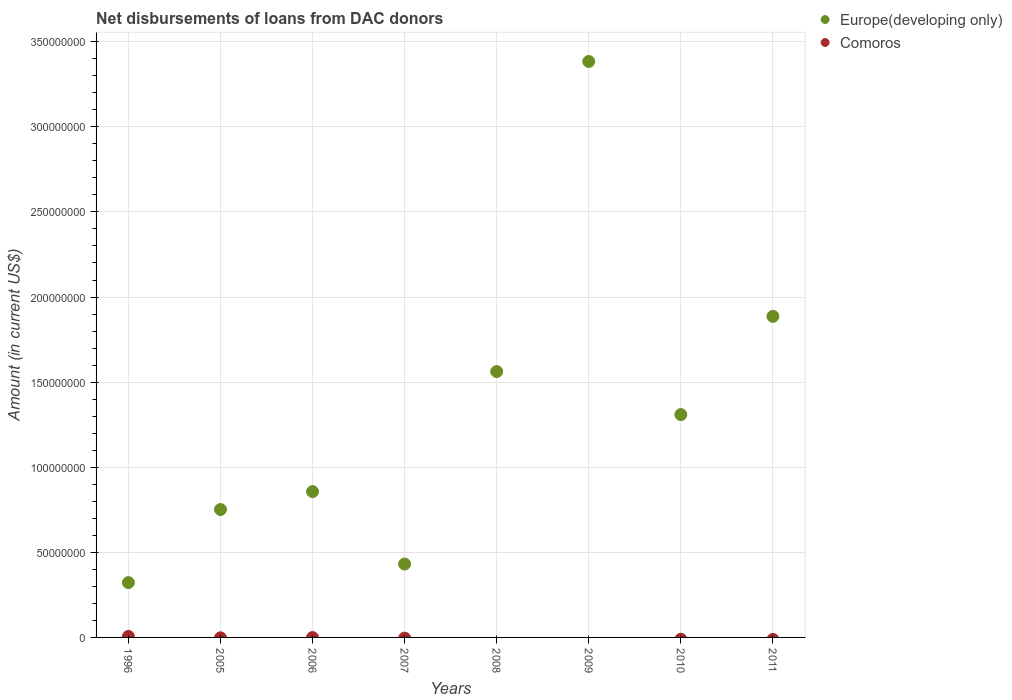Is the number of dotlines equal to the number of legend labels?
Your answer should be compact. No. What is the amount of loans disbursed in Comoros in 2009?
Your response must be concise. 0. Across all years, what is the maximum amount of loans disbursed in Comoros?
Your response must be concise. 5.95e+05. In which year was the amount of loans disbursed in Comoros maximum?
Provide a succinct answer. 1996. What is the total amount of loans disbursed in Europe(developing only) in the graph?
Your answer should be very brief. 1.05e+09. What is the difference between the amount of loans disbursed in Europe(developing only) in 2010 and that in 2011?
Your answer should be very brief. -5.77e+07. What is the difference between the amount of loans disbursed in Europe(developing only) in 2011 and the amount of loans disbursed in Comoros in 2005?
Your answer should be compact. 1.89e+08. What is the average amount of loans disbursed in Europe(developing only) per year?
Provide a succinct answer. 1.31e+08. In the year 1996, what is the difference between the amount of loans disbursed in Europe(developing only) and amount of loans disbursed in Comoros?
Provide a short and direct response. 3.16e+07. What is the ratio of the amount of loans disbursed in Europe(developing only) in 2006 to that in 2007?
Offer a terse response. 1.99. Is the amount of loans disbursed in Europe(developing only) in 2006 less than that in 2011?
Make the answer very short. Yes. What is the difference between the highest and the second highest amount of loans disbursed in Europe(developing only)?
Give a very brief answer. 1.50e+08. What is the difference between the highest and the lowest amount of loans disbursed in Comoros?
Give a very brief answer. 5.95e+05. Is the sum of the amount of loans disbursed in Europe(developing only) in 1996 and 2011 greater than the maximum amount of loans disbursed in Comoros across all years?
Provide a short and direct response. Yes. Does the amount of loans disbursed in Europe(developing only) monotonically increase over the years?
Ensure brevity in your answer.  No. Is the amount of loans disbursed in Comoros strictly less than the amount of loans disbursed in Europe(developing only) over the years?
Ensure brevity in your answer.  Yes. How many dotlines are there?
Ensure brevity in your answer.  2. What is the difference between two consecutive major ticks on the Y-axis?
Offer a terse response. 5.00e+07. How many legend labels are there?
Your answer should be compact. 2. What is the title of the graph?
Make the answer very short. Net disbursements of loans from DAC donors. What is the label or title of the Y-axis?
Offer a very short reply. Amount (in current US$). What is the Amount (in current US$) of Europe(developing only) in 1996?
Your answer should be compact. 3.22e+07. What is the Amount (in current US$) of Comoros in 1996?
Your answer should be compact. 5.95e+05. What is the Amount (in current US$) of Europe(developing only) in 2005?
Provide a succinct answer. 7.52e+07. What is the Amount (in current US$) in Europe(developing only) in 2006?
Your answer should be very brief. 8.57e+07. What is the Amount (in current US$) of Europe(developing only) in 2007?
Offer a very short reply. 4.31e+07. What is the Amount (in current US$) in Europe(developing only) in 2008?
Give a very brief answer. 1.56e+08. What is the Amount (in current US$) of Europe(developing only) in 2009?
Give a very brief answer. 3.38e+08. What is the Amount (in current US$) in Europe(developing only) in 2010?
Your answer should be compact. 1.31e+08. What is the Amount (in current US$) in Comoros in 2010?
Make the answer very short. 0. What is the Amount (in current US$) in Europe(developing only) in 2011?
Keep it short and to the point. 1.89e+08. Across all years, what is the maximum Amount (in current US$) in Europe(developing only)?
Offer a very short reply. 3.38e+08. Across all years, what is the maximum Amount (in current US$) of Comoros?
Your answer should be compact. 5.95e+05. Across all years, what is the minimum Amount (in current US$) of Europe(developing only)?
Offer a very short reply. 3.22e+07. What is the total Amount (in current US$) of Europe(developing only) in the graph?
Offer a very short reply. 1.05e+09. What is the total Amount (in current US$) of Comoros in the graph?
Make the answer very short. 5.95e+05. What is the difference between the Amount (in current US$) of Europe(developing only) in 1996 and that in 2005?
Keep it short and to the point. -4.29e+07. What is the difference between the Amount (in current US$) of Europe(developing only) in 1996 and that in 2006?
Offer a very short reply. -5.35e+07. What is the difference between the Amount (in current US$) of Europe(developing only) in 1996 and that in 2007?
Keep it short and to the point. -1.09e+07. What is the difference between the Amount (in current US$) in Europe(developing only) in 1996 and that in 2008?
Provide a short and direct response. -1.24e+08. What is the difference between the Amount (in current US$) of Europe(developing only) in 1996 and that in 2009?
Your response must be concise. -3.06e+08. What is the difference between the Amount (in current US$) of Europe(developing only) in 1996 and that in 2010?
Provide a short and direct response. -9.87e+07. What is the difference between the Amount (in current US$) in Europe(developing only) in 1996 and that in 2011?
Offer a terse response. -1.56e+08. What is the difference between the Amount (in current US$) of Europe(developing only) in 2005 and that in 2006?
Provide a succinct answer. -1.05e+07. What is the difference between the Amount (in current US$) of Europe(developing only) in 2005 and that in 2007?
Provide a succinct answer. 3.20e+07. What is the difference between the Amount (in current US$) in Europe(developing only) in 2005 and that in 2008?
Provide a short and direct response. -8.11e+07. What is the difference between the Amount (in current US$) in Europe(developing only) in 2005 and that in 2009?
Keep it short and to the point. -2.63e+08. What is the difference between the Amount (in current US$) of Europe(developing only) in 2005 and that in 2010?
Your response must be concise. -5.58e+07. What is the difference between the Amount (in current US$) in Europe(developing only) in 2005 and that in 2011?
Make the answer very short. -1.13e+08. What is the difference between the Amount (in current US$) in Europe(developing only) in 2006 and that in 2007?
Your answer should be very brief. 4.26e+07. What is the difference between the Amount (in current US$) of Europe(developing only) in 2006 and that in 2008?
Your response must be concise. -7.05e+07. What is the difference between the Amount (in current US$) of Europe(developing only) in 2006 and that in 2009?
Provide a short and direct response. -2.53e+08. What is the difference between the Amount (in current US$) in Europe(developing only) in 2006 and that in 2010?
Your response must be concise. -4.52e+07. What is the difference between the Amount (in current US$) in Europe(developing only) in 2006 and that in 2011?
Your answer should be very brief. -1.03e+08. What is the difference between the Amount (in current US$) of Europe(developing only) in 2007 and that in 2008?
Ensure brevity in your answer.  -1.13e+08. What is the difference between the Amount (in current US$) of Europe(developing only) in 2007 and that in 2009?
Ensure brevity in your answer.  -2.95e+08. What is the difference between the Amount (in current US$) in Europe(developing only) in 2007 and that in 2010?
Provide a succinct answer. -8.78e+07. What is the difference between the Amount (in current US$) of Europe(developing only) in 2007 and that in 2011?
Your answer should be compact. -1.46e+08. What is the difference between the Amount (in current US$) in Europe(developing only) in 2008 and that in 2009?
Offer a very short reply. -1.82e+08. What is the difference between the Amount (in current US$) of Europe(developing only) in 2008 and that in 2010?
Keep it short and to the point. 2.53e+07. What is the difference between the Amount (in current US$) of Europe(developing only) in 2008 and that in 2011?
Offer a terse response. -3.24e+07. What is the difference between the Amount (in current US$) in Europe(developing only) in 2009 and that in 2010?
Ensure brevity in your answer.  2.07e+08. What is the difference between the Amount (in current US$) of Europe(developing only) in 2009 and that in 2011?
Give a very brief answer. 1.50e+08. What is the difference between the Amount (in current US$) of Europe(developing only) in 2010 and that in 2011?
Offer a terse response. -5.77e+07. What is the average Amount (in current US$) in Europe(developing only) per year?
Provide a short and direct response. 1.31e+08. What is the average Amount (in current US$) of Comoros per year?
Your response must be concise. 7.44e+04. In the year 1996, what is the difference between the Amount (in current US$) in Europe(developing only) and Amount (in current US$) in Comoros?
Give a very brief answer. 3.16e+07. What is the ratio of the Amount (in current US$) in Europe(developing only) in 1996 to that in 2005?
Make the answer very short. 0.43. What is the ratio of the Amount (in current US$) of Europe(developing only) in 1996 to that in 2006?
Make the answer very short. 0.38. What is the ratio of the Amount (in current US$) in Europe(developing only) in 1996 to that in 2007?
Provide a succinct answer. 0.75. What is the ratio of the Amount (in current US$) of Europe(developing only) in 1996 to that in 2008?
Provide a short and direct response. 0.21. What is the ratio of the Amount (in current US$) in Europe(developing only) in 1996 to that in 2009?
Your answer should be compact. 0.1. What is the ratio of the Amount (in current US$) of Europe(developing only) in 1996 to that in 2010?
Your response must be concise. 0.25. What is the ratio of the Amount (in current US$) in Europe(developing only) in 1996 to that in 2011?
Keep it short and to the point. 0.17. What is the ratio of the Amount (in current US$) in Europe(developing only) in 2005 to that in 2006?
Your response must be concise. 0.88. What is the ratio of the Amount (in current US$) in Europe(developing only) in 2005 to that in 2007?
Ensure brevity in your answer.  1.74. What is the ratio of the Amount (in current US$) in Europe(developing only) in 2005 to that in 2008?
Your answer should be compact. 0.48. What is the ratio of the Amount (in current US$) of Europe(developing only) in 2005 to that in 2009?
Provide a short and direct response. 0.22. What is the ratio of the Amount (in current US$) of Europe(developing only) in 2005 to that in 2010?
Your response must be concise. 0.57. What is the ratio of the Amount (in current US$) in Europe(developing only) in 2005 to that in 2011?
Offer a terse response. 0.4. What is the ratio of the Amount (in current US$) of Europe(developing only) in 2006 to that in 2007?
Keep it short and to the point. 1.99. What is the ratio of the Amount (in current US$) in Europe(developing only) in 2006 to that in 2008?
Your response must be concise. 0.55. What is the ratio of the Amount (in current US$) of Europe(developing only) in 2006 to that in 2009?
Your response must be concise. 0.25. What is the ratio of the Amount (in current US$) of Europe(developing only) in 2006 to that in 2010?
Your answer should be very brief. 0.65. What is the ratio of the Amount (in current US$) of Europe(developing only) in 2006 to that in 2011?
Ensure brevity in your answer.  0.45. What is the ratio of the Amount (in current US$) in Europe(developing only) in 2007 to that in 2008?
Your answer should be very brief. 0.28. What is the ratio of the Amount (in current US$) of Europe(developing only) in 2007 to that in 2009?
Your response must be concise. 0.13. What is the ratio of the Amount (in current US$) of Europe(developing only) in 2007 to that in 2010?
Offer a very short reply. 0.33. What is the ratio of the Amount (in current US$) in Europe(developing only) in 2007 to that in 2011?
Your answer should be very brief. 0.23. What is the ratio of the Amount (in current US$) of Europe(developing only) in 2008 to that in 2009?
Offer a very short reply. 0.46. What is the ratio of the Amount (in current US$) in Europe(developing only) in 2008 to that in 2010?
Your answer should be compact. 1.19. What is the ratio of the Amount (in current US$) of Europe(developing only) in 2008 to that in 2011?
Give a very brief answer. 0.83. What is the ratio of the Amount (in current US$) of Europe(developing only) in 2009 to that in 2010?
Provide a succinct answer. 2.58. What is the ratio of the Amount (in current US$) of Europe(developing only) in 2009 to that in 2011?
Your answer should be very brief. 1.79. What is the ratio of the Amount (in current US$) in Europe(developing only) in 2010 to that in 2011?
Provide a short and direct response. 0.69. What is the difference between the highest and the second highest Amount (in current US$) of Europe(developing only)?
Keep it short and to the point. 1.50e+08. What is the difference between the highest and the lowest Amount (in current US$) of Europe(developing only)?
Keep it short and to the point. 3.06e+08. What is the difference between the highest and the lowest Amount (in current US$) of Comoros?
Offer a very short reply. 5.95e+05. 